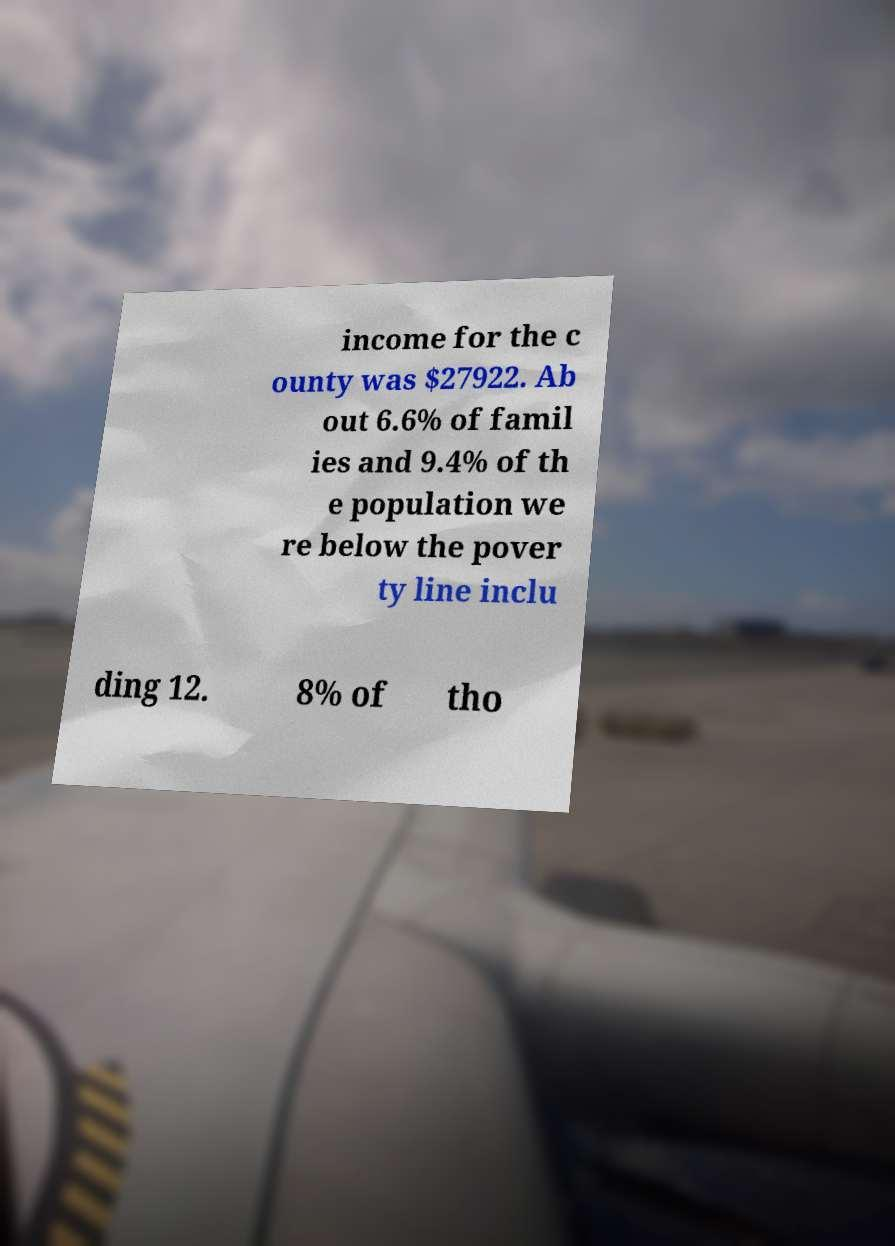For documentation purposes, I need the text within this image transcribed. Could you provide that? income for the c ounty was $27922. Ab out 6.6% of famil ies and 9.4% of th e population we re below the pover ty line inclu ding 12. 8% of tho 